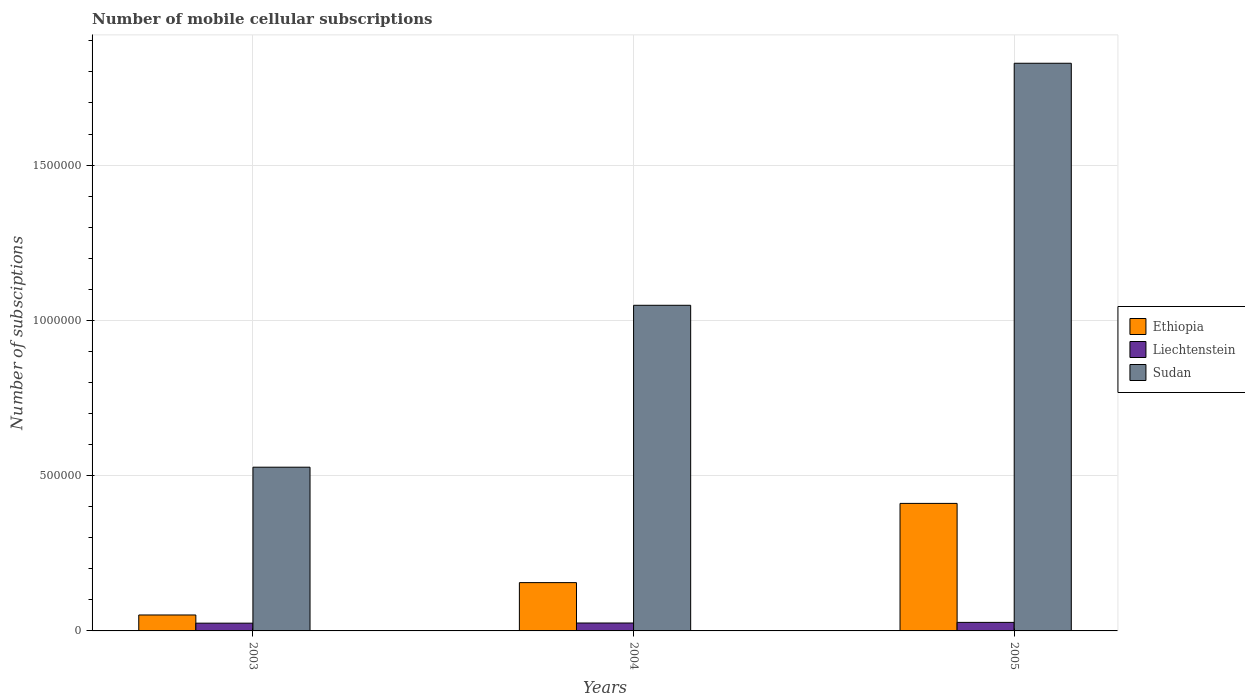How many different coloured bars are there?
Your answer should be compact. 3. Are the number of bars per tick equal to the number of legend labels?
Your answer should be very brief. Yes. Are the number of bars on each tick of the X-axis equal?
Provide a short and direct response. Yes. How many bars are there on the 1st tick from the left?
Ensure brevity in your answer.  3. In how many cases, is the number of bars for a given year not equal to the number of legend labels?
Your answer should be very brief. 0. What is the number of mobile cellular subscriptions in Sudan in 2003?
Ensure brevity in your answer.  5.27e+05. Across all years, what is the maximum number of mobile cellular subscriptions in Sudan?
Provide a succinct answer. 1.83e+06. Across all years, what is the minimum number of mobile cellular subscriptions in Sudan?
Offer a terse response. 5.27e+05. In which year was the number of mobile cellular subscriptions in Ethiopia maximum?
Your answer should be compact. 2005. What is the total number of mobile cellular subscriptions in Ethiopia in the graph?
Provide a succinct answer. 6.17e+05. What is the difference between the number of mobile cellular subscriptions in Sudan in 2003 and that in 2004?
Provide a succinct answer. -5.21e+05. What is the difference between the number of mobile cellular subscriptions in Ethiopia in 2003 and the number of mobile cellular subscriptions in Sudan in 2005?
Your answer should be compact. -1.78e+06. What is the average number of mobile cellular subscriptions in Liechtenstein per year?
Provide a succinct answer. 2.60e+04. In the year 2003, what is the difference between the number of mobile cellular subscriptions in Ethiopia and number of mobile cellular subscriptions in Sudan?
Keep it short and to the point. -4.76e+05. In how many years, is the number of mobile cellular subscriptions in Liechtenstein greater than 600000?
Offer a very short reply. 0. What is the ratio of the number of mobile cellular subscriptions in Liechtenstein in 2004 to that in 2005?
Your response must be concise. 0.93. Is the difference between the number of mobile cellular subscriptions in Ethiopia in 2003 and 2004 greater than the difference between the number of mobile cellular subscriptions in Sudan in 2003 and 2004?
Your answer should be compact. Yes. What is the difference between the highest and the second highest number of mobile cellular subscriptions in Ethiopia?
Provide a succinct answer. 2.55e+05. What is the difference between the highest and the lowest number of mobile cellular subscriptions in Sudan?
Your response must be concise. 1.30e+06. In how many years, is the number of mobile cellular subscriptions in Sudan greater than the average number of mobile cellular subscriptions in Sudan taken over all years?
Provide a short and direct response. 1. What does the 1st bar from the left in 2004 represents?
Your response must be concise. Ethiopia. What does the 2nd bar from the right in 2004 represents?
Your answer should be compact. Liechtenstein. How many years are there in the graph?
Provide a succinct answer. 3. Does the graph contain any zero values?
Your response must be concise. No. Does the graph contain grids?
Provide a short and direct response. Yes. Where does the legend appear in the graph?
Keep it short and to the point. Center right. How many legend labels are there?
Provide a succinct answer. 3. What is the title of the graph?
Your answer should be very brief. Number of mobile cellular subscriptions. What is the label or title of the Y-axis?
Your answer should be very brief. Number of subsciptions. What is the Number of subsciptions of Ethiopia in 2003?
Offer a terse response. 5.13e+04. What is the Number of subsciptions in Liechtenstein in 2003?
Keep it short and to the point. 2.50e+04. What is the Number of subsciptions in Sudan in 2003?
Provide a short and direct response. 5.27e+05. What is the Number of subsciptions in Ethiopia in 2004?
Your answer should be compact. 1.56e+05. What is the Number of subsciptions of Liechtenstein in 2004?
Your answer should be very brief. 2.55e+04. What is the Number of subsciptions in Sudan in 2004?
Ensure brevity in your answer.  1.05e+06. What is the Number of subsciptions of Ethiopia in 2005?
Give a very brief answer. 4.11e+05. What is the Number of subsciptions in Liechtenstein in 2005?
Provide a succinct answer. 2.75e+04. What is the Number of subsciptions in Sudan in 2005?
Give a very brief answer. 1.83e+06. Across all years, what is the maximum Number of subsciptions of Ethiopia?
Your answer should be very brief. 4.11e+05. Across all years, what is the maximum Number of subsciptions in Liechtenstein?
Offer a terse response. 2.75e+04. Across all years, what is the maximum Number of subsciptions in Sudan?
Your response must be concise. 1.83e+06. Across all years, what is the minimum Number of subsciptions of Ethiopia?
Make the answer very short. 5.13e+04. Across all years, what is the minimum Number of subsciptions in Liechtenstein?
Your response must be concise. 2.50e+04. Across all years, what is the minimum Number of subsciptions of Sudan?
Keep it short and to the point. 5.27e+05. What is the total Number of subsciptions in Ethiopia in the graph?
Offer a very short reply. 6.17e+05. What is the total Number of subsciptions of Liechtenstein in the graph?
Offer a very short reply. 7.80e+04. What is the total Number of subsciptions in Sudan in the graph?
Your answer should be compact. 3.40e+06. What is the difference between the Number of subsciptions of Ethiopia in 2003 and that in 2004?
Your response must be concise. -1.04e+05. What is the difference between the Number of subsciptions of Liechtenstein in 2003 and that in 2004?
Give a very brief answer. -500. What is the difference between the Number of subsciptions of Sudan in 2003 and that in 2004?
Provide a succinct answer. -5.21e+05. What is the difference between the Number of subsciptions in Ethiopia in 2003 and that in 2005?
Offer a terse response. -3.59e+05. What is the difference between the Number of subsciptions in Liechtenstein in 2003 and that in 2005?
Your answer should be very brief. -2503. What is the difference between the Number of subsciptions in Sudan in 2003 and that in 2005?
Give a very brief answer. -1.30e+06. What is the difference between the Number of subsciptions of Ethiopia in 2004 and that in 2005?
Keep it short and to the point. -2.55e+05. What is the difference between the Number of subsciptions in Liechtenstein in 2004 and that in 2005?
Offer a very short reply. -2003. What is the difference between the Number of subsciptions in Sudan in 2004 and that in 2005?
Offer a terse response. -7.79e+05. What is the difference between the Number of subsciptions of Ethiopia in 2003 and the Number of subsciptions of Liechtenstein in 2004?
Offer a very short reply. 2.58e+04. What is the difference between the Number of subsciptions of Ethiopia in 2003 and the Number of subsciptions of Sudan in 2004?
Make the answer very short. -9.97e+05. What is the difference between the Number of subsciptions in Liechtenstein in 2003 and the Number of subsciptions in Sudan in 2004?
Give a very brief answer. -1.02e+06. What is the difference between the Number of subsciptions in Ethiopia in 2003 and the Number of subsciptions in Liechtenstein in 2005?
Your answer should be very brief. 2.38e+04. What is the difference between the Number of subsciptions in Ethiopia in 2003 and the Number of subsciptions in Sudan in 2005?
Provide a succinct answer. -1.78e+06. What is the difference between the Number of subsciptions in Liechtenstein in 2003 and the Number of subsciptions in Sudan in 2005?
Give a very brief answer. -1.80e+06. What is the difference between the Number of subsciptions of Ethiopia in 2004 and the Number of subsciptions of Liechtenstein in 2005?
Offer a very short reply. 1.28e+05. What is the difference between the Number of subsciptions in Ethiopia in 2004 and the Number of subsciptions in Sudan in 2005?
Offer a very short reply. -1.67e+06. What is the difference between the Number of subsciptions of Liechtenstein in 2004 and the Number of subsciptions of Sudan in 2005?
Your answer should be very brief. -1.80e+06. What is the average Number of subsciptions in Ethiopia per year?
Make the answer very short. 2.06e+05. What is the average Number of subsciptions in Liechtenstein per year?
Your answer should be compact. 2.60e+04. What is the average Number of subsciptions of Sudan per year?
Offer a very short reply. 1.13e+06. In the year 2003, what is the difference between the Number of subsciptions in Ethiopia and Number of subsciptions in Liechtenstein?
Keep it short and to the point. 2.63e+04. In the year 2003, what is the difference between the Number of subsciptions in Ethiopia and Number of subsciptions in Sudan?
Offer a terse response. -4.76e+05. In the year 2003, what is the difference between the Number of subsciptions of Liechtenstein and Number of subsciptions of Sudan?
Make the answer very short. -5.02e+05. In the year 2004, what is the difference between the Number of subsciptions in Ethiopia and Number of subsciptions in Liechtenstein?
Offer a very short reply. 1.30e+05. In the year 2004, what is the difference between the Number of subsciptions in Ethiopia and Number of subsciptions in Sudan?
Your answer should be compact. -8.93e+05. In the year 2004, what is the difference between the Number of subsciptions of Liechtenstein and Number of subsciptions of Sudan?
Provide a succinct answer. -1.02e+06. In the year 2005, what is the difference between the Number of subsciptions in Ethiopia and Number of subsciptions in Liechtenstein?
Give a very brief answer. 3.83e+05. In the year 2005, what is the difference between the Number of subsciptions in Ethiopia and Number of subsciptions in Sudan?
Give a very brief answer. -1.42e+06. In the year 2005, what is the difference between the Number of subsciptions of Liechtenstein and Number of subsciptions of Sudan?
Your answer should be very brief. -1.80e+06. What is the ratio of the Number of subsciptions in Ethiopia in 2003 to that in 2004?
Provide a short and direct response. 0.33. What is the ratio of the Number of subsciptions of Liechtenstein in 2003 to that in 2004?
Your answer should be compact. 0.98. What is the ratio of the Number of subsciptions of Sudan in 2003 to that in 2004?
Provide a succinct answer. 0.5. What is the ratio of the Number of subsciptions in Liechtenstein in 2003 to that in 2005?
Ensure brevity in your answer.  0.91. What is the ratio of the Number of subsciptions in Sudan in 2003 to that in 2005?
Make the answer very short. 0.29. What is the ratio of the Number of subsciptions of Ethiopia in 2004 to that in 2005?
Your answer should be very brief. 0.38. What is the ratio of the Number of subsciptions in Liechtenstein in 2004 to that in 2005?
Offer a terse response. 0.93. What is the ratio of the Number of subsciptions in Sudan in 2004 to that in 2005?
Offer a very short reply. 0.57. What is the difference between the highest and the second highest Number of subsciptions in Ethiopia?
Offer a very short reply. 2.55e+05. What is the difference between the highest and the second highest Number of subsciptions of Liechtenstein?
Make the answer very short. 2003. What is the difference between the highest and the second highest Number of subsciptions of Sudan?
Offer a terse response. 7.79e+05. What is the difference between the highest and the lowest Number of subsciptions of Ethiopia?
Ensure brevity in your answer.  3.59e+05. What is the difference between the highest and the lowest Number of subsciptions in Liechtenstein?
Ensure brevity in your answer.  2503. What is the difference between the highest and the lowest Number of subsciptions of Sudan?
Offer a terse response. 1.30e+06. 